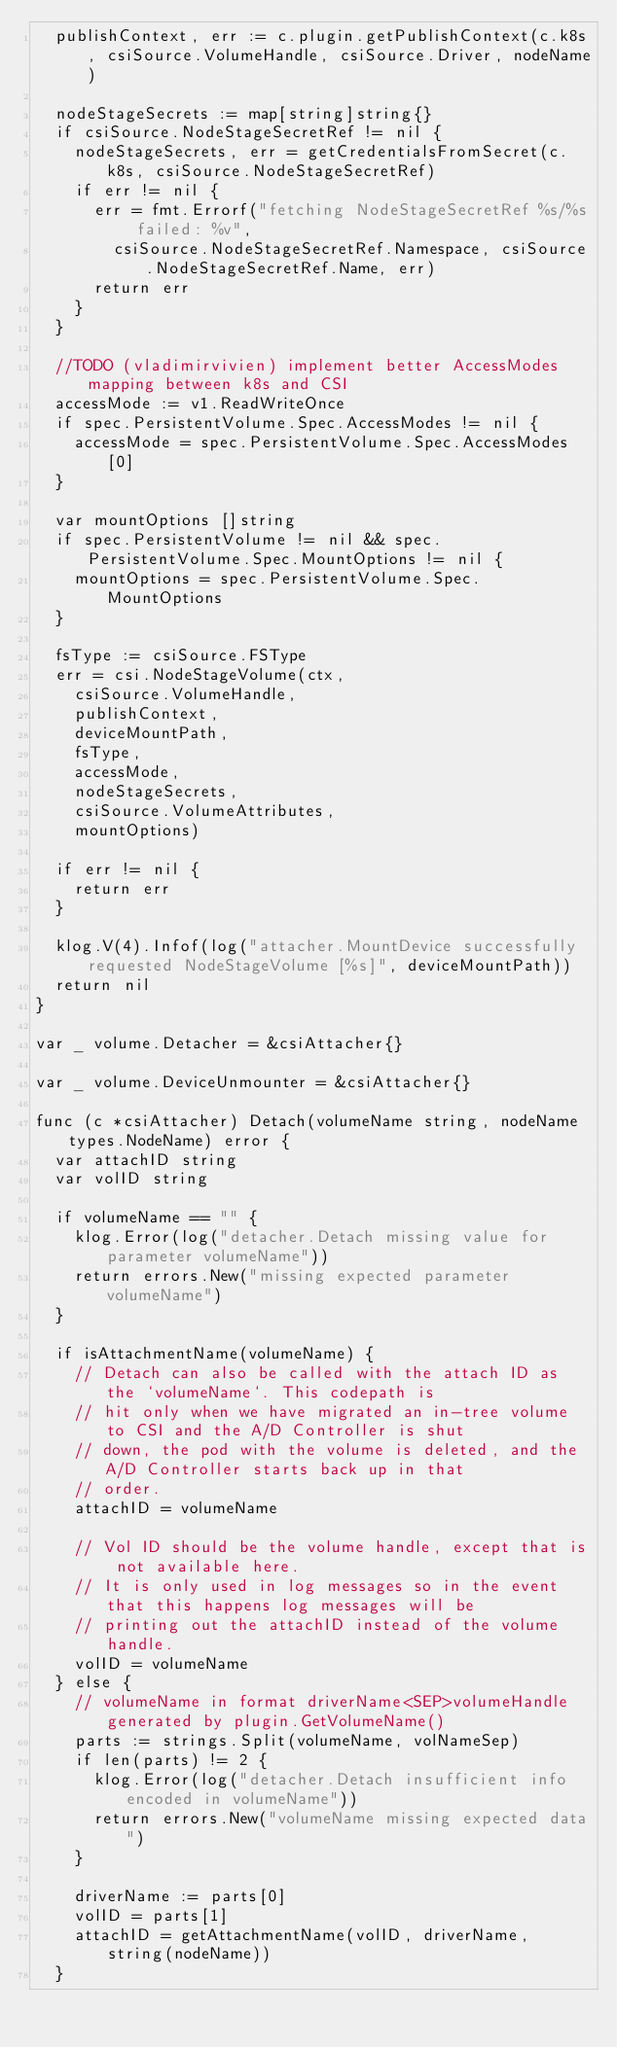<code> <loc_0><loc_0><loc_500><loc_500><_Go_>	publishContext, err := c.plugin.getPublishContext(c.k8s, csiSource.VolumeHandle, csiSource.Driver, nodeName)

	nodeStageSecrets := map[string]string{}
	if csiSource.NodeStageSecretRef != nil {
		nodeStageSecrets, err = getCredentialsFromSecret(c.k8s, csiSource.NodeStageSecretRef)
		if err != nil {
			err = fmt.Errorf("fetching NodeStageSecretRef %s/%s failed: %v",
				csiSource.NodeStageSecretRef.Namespace, csiSource.NodeStageSecretRef.Name, err)
			return err
		}
	}

	//TODO (vladimirvivien) implement better AccessModes mapping between k8s and CSI
	accessMode := v1.ReadWriteOnce
	if spec.PersistentVolume.Spec.AccessModes != nil {
		accessMode = spec.PersistentVolume.Spec.AccessModes[0]
	}

	var mountOptions []string
	if spec.PersistentVolume != nil && spec.PersistentVolume.Spec.MountOptions != nil {
		mountOptions = spec.PersistentVolume.Spec.MountOptions
	}

	fsType := csiSource.FSType
	err = csi.NodeStageVolume(ctx,
		csiSource.VolumeHandle,
		publishContext,
		deviceMountPath,
		fsType,
		accessMode,
		nodeStageSecrets,
		csiSource.VolumeAttributes,
		mountOptions)

	if err != nil {
		return err
	}

	klog.V(4).Infof(log("attacher.MountDevice successfully requested NodeStageVolume [%s]", deviceMountPath))
	return nil
}

var _ volume.Detacher = &csiAttacher{}

var _ volume.DeviceUnmounter = &csiAttacher{}

func (c *csiAttacher) Detach(volumeName string, nodeName types.NodeName) error {
	var attachID string
	var volID string

	if volumeName == "" {
		klog.Error(log("detacher.Detach missing value for parameter volumeName"))
		return errors.New("missing expected parameter volumeName")
	}

	if isAttachmentName(volumeName) {
		// Detach can also be called with the attach ID as the `volumeName`. This codepath is
		// hit only when we have migrated an in-tree volume to CSI and the A/D Controller is shut
		// down, the pod with the volume is deleted, and the A/D Controller starts back up in that
		// order.
		attachID = volumeName

		// Vol ID should be the volume handle, except that is not available here.
		// It is only used in log messages so in the event that this happens log messages will be
		// printing out the attachID instead of the volume handle.
		volID = volumeName
	} else {
		// volumeName in format driverName<SEP>volumeHandle generated by plugin.GetVolumeName()
		parts := strings.Split(volumeName, volNameSep)
		if len(parts) != 2 {
			klog.Error(log("detacher.Detach insufficient info encoded in volumeName"))
			return errors.New("volumeName missing expected data")
		}

		driverName := parts[0]
		volID = parts[1]
		attachID = getAttachmentName(volID, driverName, string(nodeName))
	}
</code> 